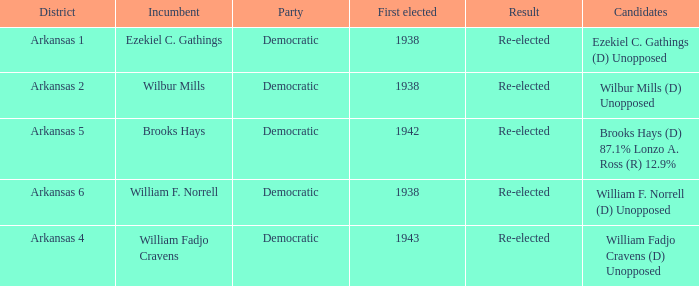What party did the incumbent of the Arkansas 6 district belong to?  Democratic. Can you give me this table as a dict? {'header': ['District', 'Incumbent', 'Party', 'First elected', 'Result', 'Candidates'], 'rows': [['Arkansas 1', 'Ezekiel C. Gathings', 'Democratic', '1938', 'Re-elected', 'Ezekiel C. Gathings (D) Unopposed'], ['Arkansas 2', 'Wilbur Mills', 'Democratic', '1938', 'Re-elected', 'Wilbur Mills (D) Unopposed'], ['Arkansas 5', 'Brooks Hays', 'Democratic', '1942', 'Re-elected', 'Brooks Hays (D) 87.1% Lonzo A. Ross (R) 12.9%'], ['Arkansas 6', 'William F. Norrell', 'Democratic', '1938', 'Re-elected', 'William F. Norrell (D) Unopposed'], ['Arkansas 4', 'William Fadjo Cravens', 'Democratic', '1943', 'Re-elected', 'William Fadjo Cravens (D) Unopposed']]} 